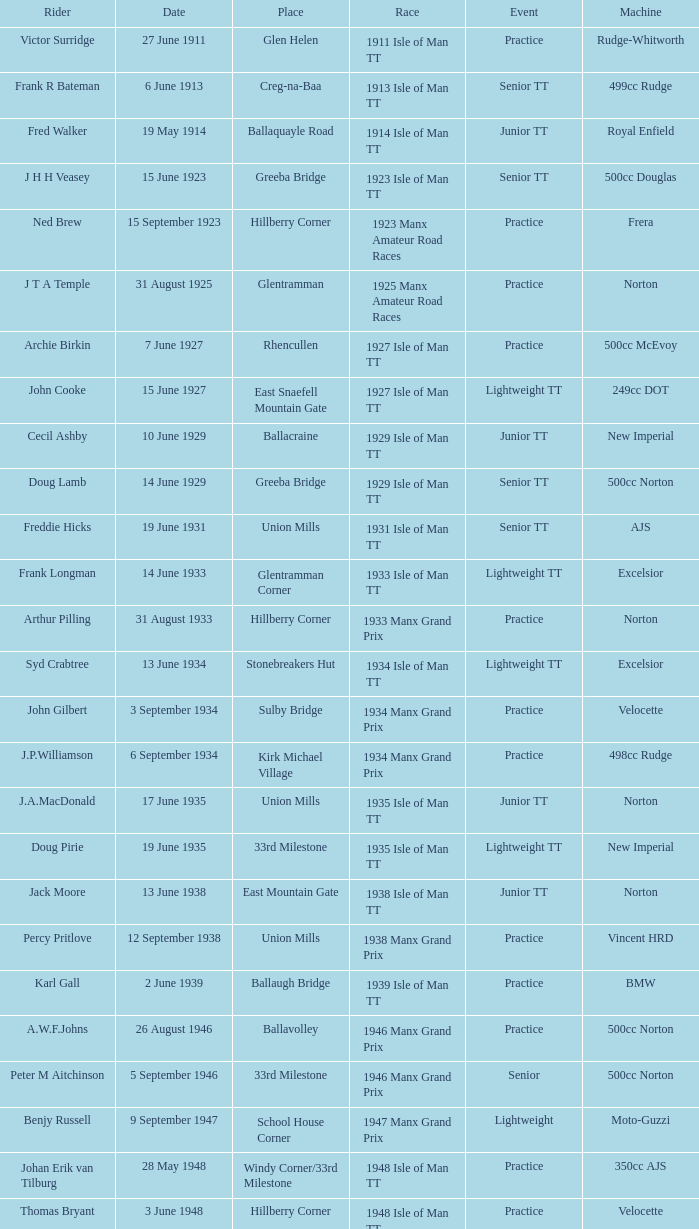Where was the 249cc Yamaha? Glentramman. 